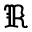<formula> <loc_0><loc_0><loc_500><loc_500>\Re</formula> 